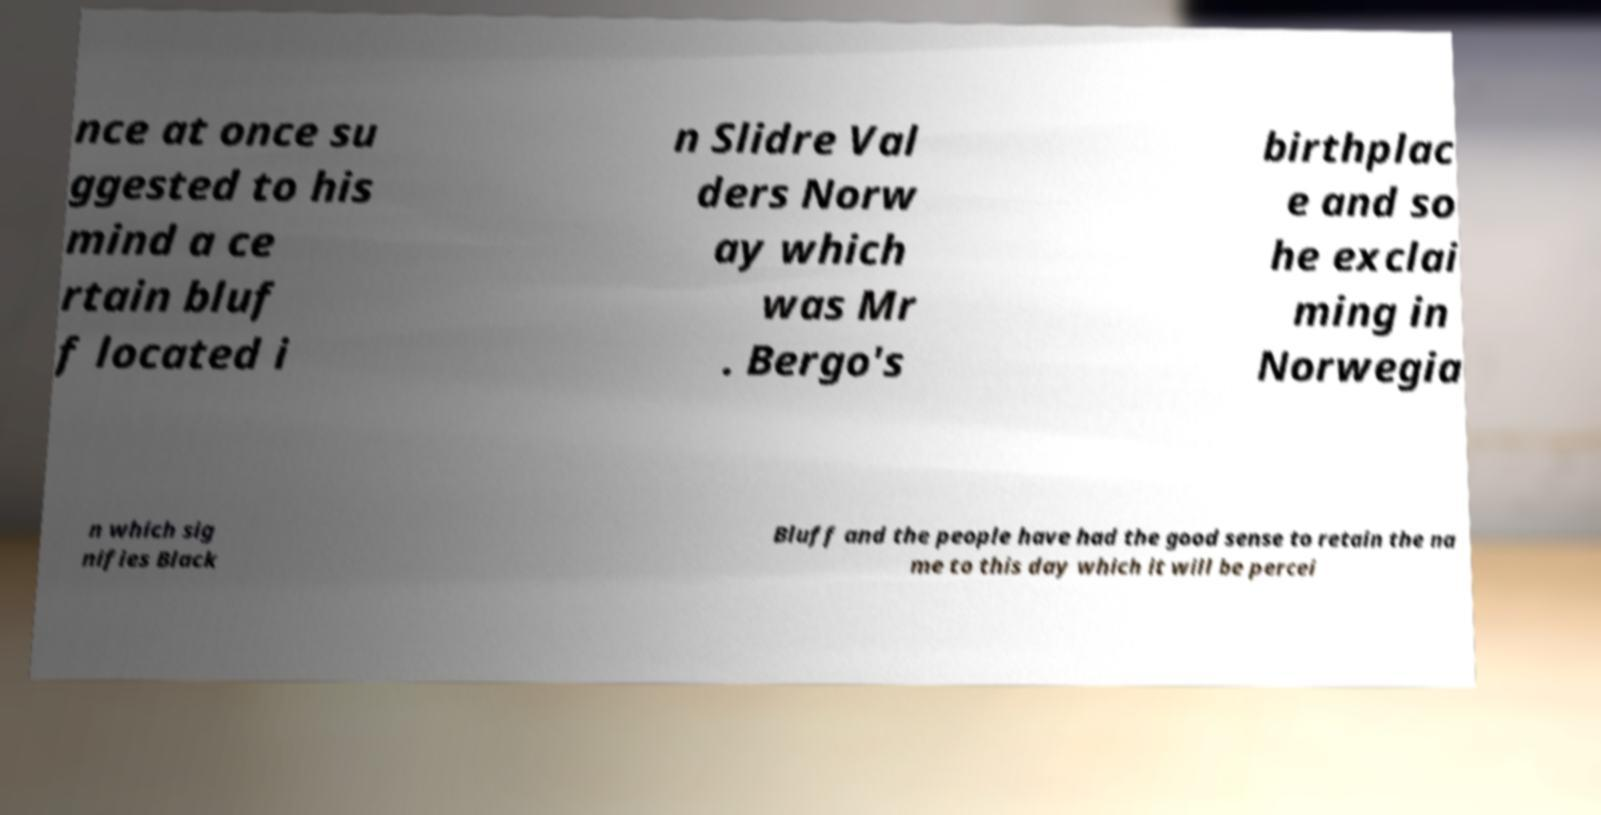There's text embedded in this image that I need extracted. Can you transcribe it verbatim? nce at once su ggested to his mind a ce rtain bluf f located i n Slidre Val ders Norw ay which was Mr . Bergo's birthplac e and so he exclai ming in Norwegia n which sig nifies Black Bluff and the people have had the good sense to retain the na me to this day which it will be percei 